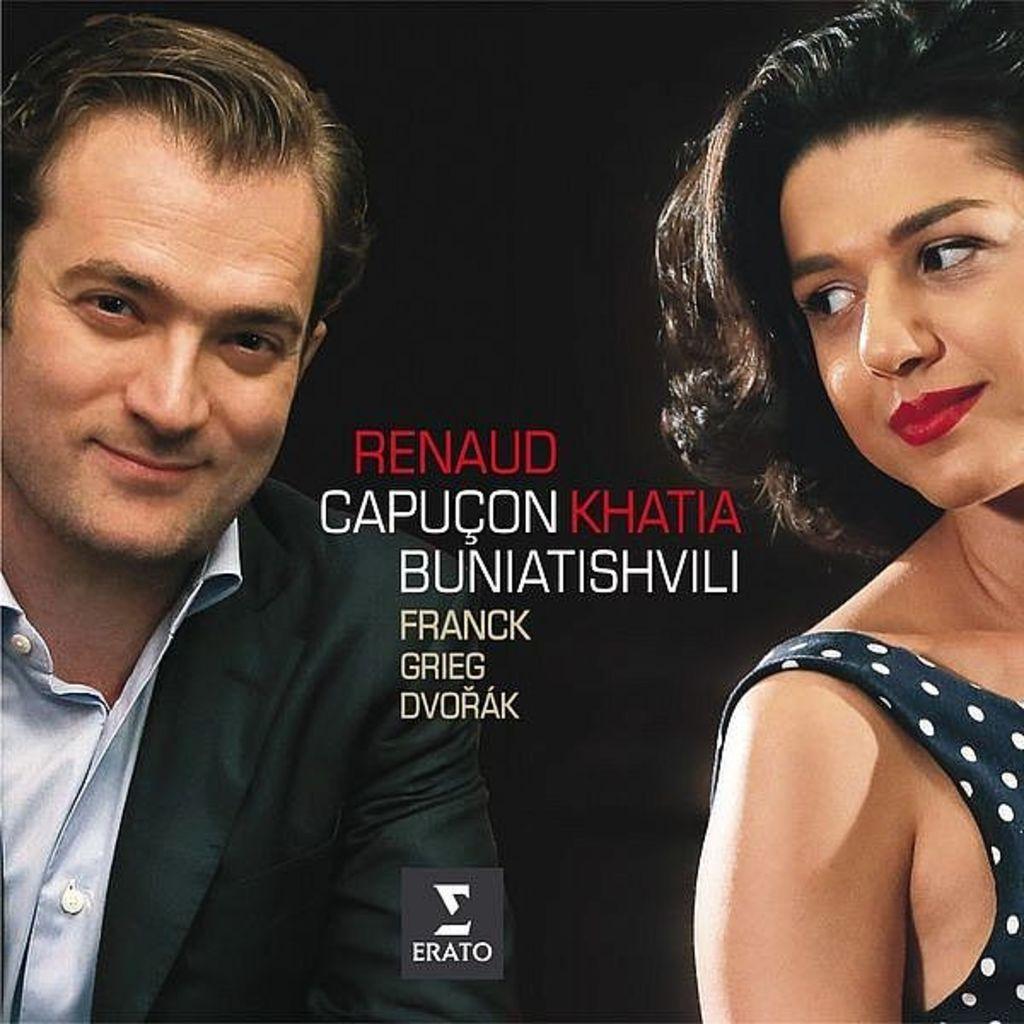Please provide a concise description of this image. In this picture we can see a man and a woman here, there is some text here, we can see dark background. 